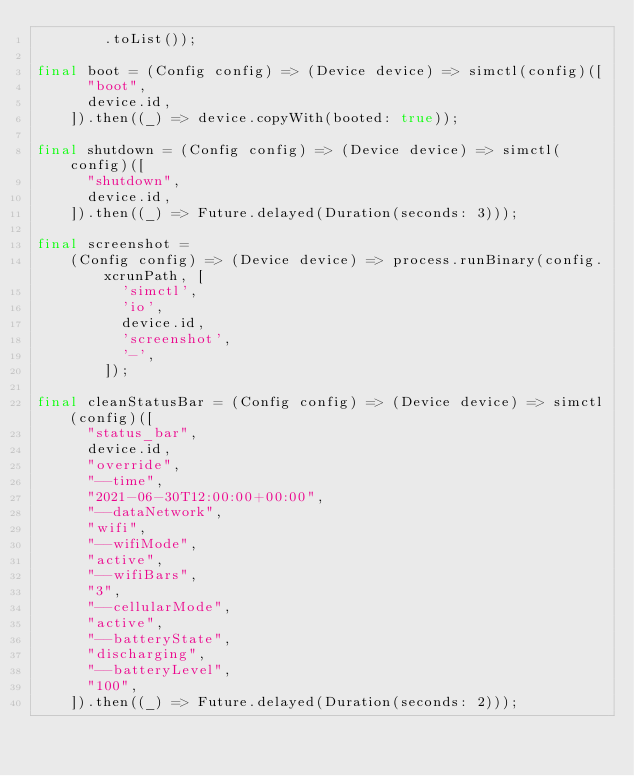<code> <loc_0><loc_0><loc_500><loc_500><_Dart_>        .toList());

final boot = (Config config) => (Device device) => simctl(config)([
      "boot",
      device.id,
    ]).then((_) => device.copyWith(booted: true));

final shutdown = (Config config) => (Device device) => simctl(config)([
      "shutdown",
      device.id,
    ]).then((_) => Future.delayed(Duration(seconds: 3)));

final screenshot =
    (Config config) => (Device device) => process.runBinary(config.xcrunPath, [
          'simctl',
          'io',
          device.id,
          'screenshot',
          '-',
        ]);

final cleanStatusBar = (Config config) => (Device device) => simctl(config)([
      "status_bar",
      device.id,
      "override",
      "--time",
      "2021-06-30T12:00:00+00:00",
      "--dataNetwork",
      "wifi",
      "--wifiMode",
      "active",
      "--wifiBars",
      "3",
      "--cellularMode",
      "active",
      "--batteryState",
      "discharging",
      "--batteryLevel",
      "100",
    ]).then((_) => Future.delayed(Duration(seconds: 2)));
</code> 